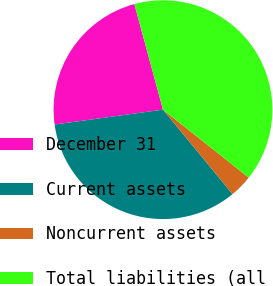Convert chart. <chart><loc_0><loc_0><loc_500><loc_500><pie_chart><fcel>December 31<fcel>Current assets<fcel>Noncurrent assets<fcel>Total liabilities (all<nl><fcel>22.96%<fcel>33.79%<fcel>3.37%<fcel>39.88%<nl></chart> 